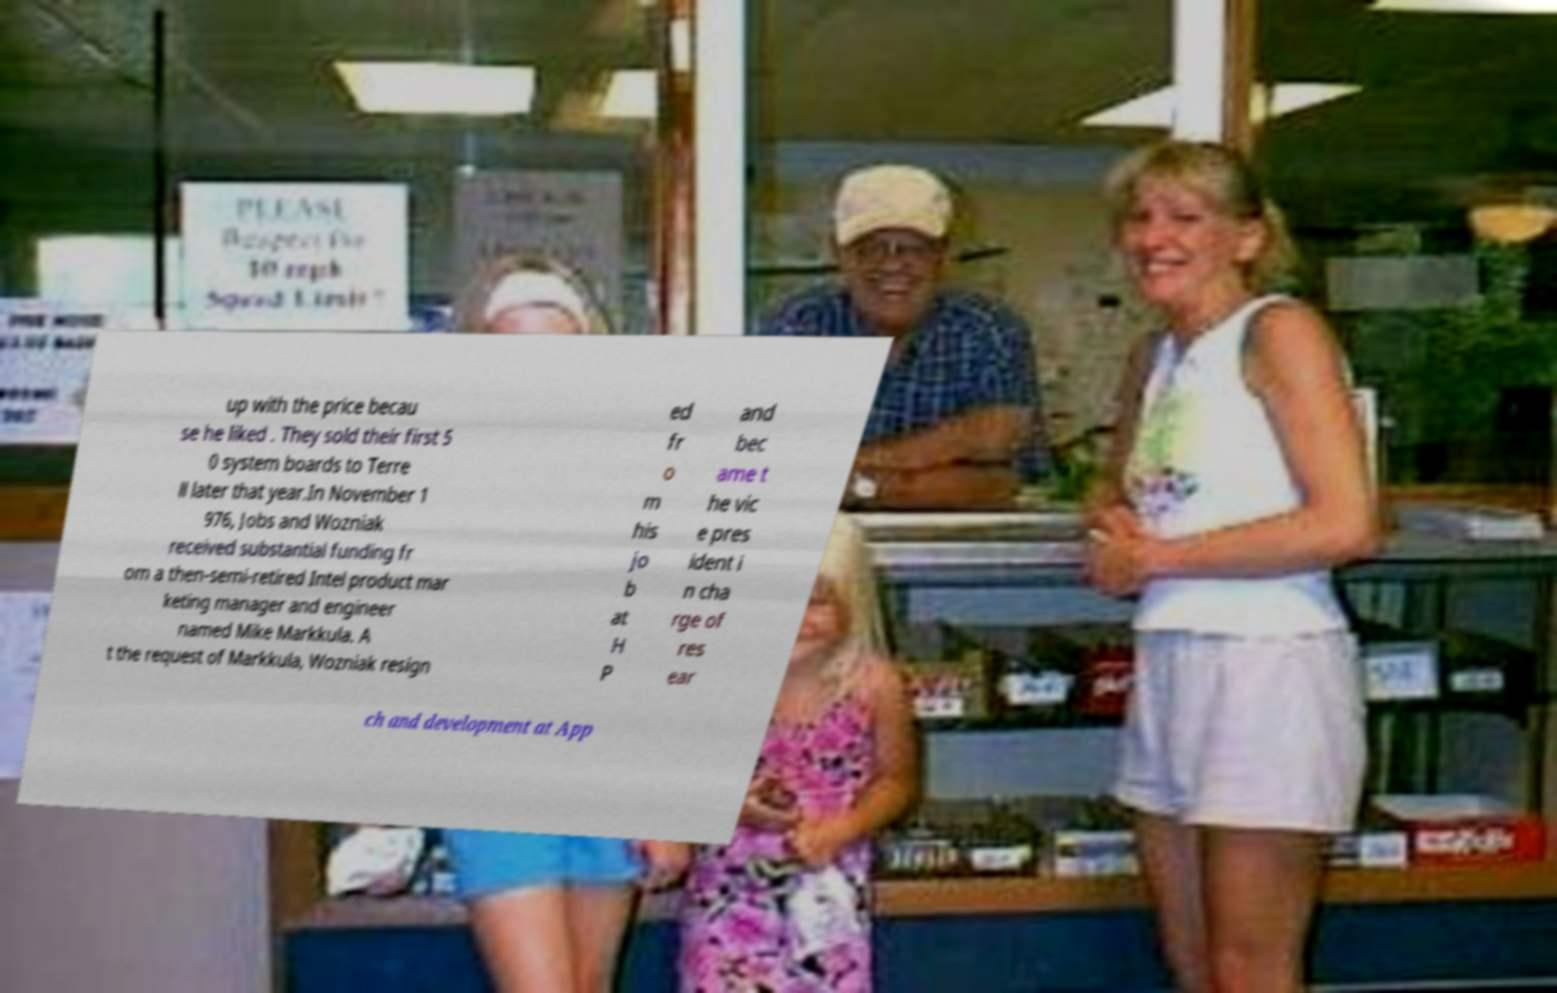Could you extract and type out the text from this image? up with the price becau se he liked . They sold their first 5 0 system boards to Terre ll later that year.In November 1 976, Jobs and Wozniak received substantial funding fr om a then-semi-retired Intel product mar keting manager and engineer named Mike Markkula. A t the request of Markkula, Wozniak resign ed fr o m his jo b at H P and bec ame t he vic e pres ident i n cha rge of res ear ch and development at App 